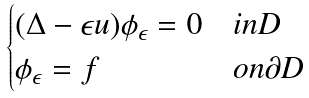<formula> <loc_0><loc_0><loc_500><loc_500>\begin{cases} ( \Delta - \epsilon u ) \phi _ { \epsilon } = 0 & i n D \\ \phi _ { \epsilon } = f & o n \partial D \end{cases}</formula> 